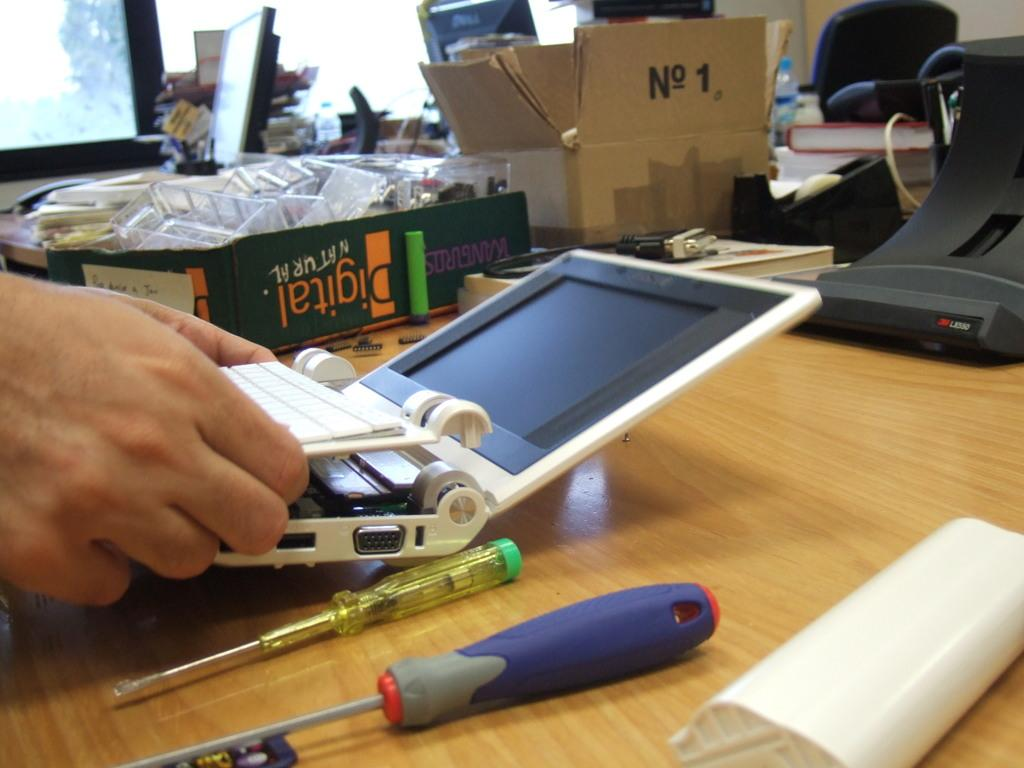<image>
Render a clear and concise summary of the photo. Person trying to fix a laptop near a box that says "No. 1". 